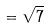<formula> <loc_0><loc_0><loc_500><loc_500>= \sqrt { 7 }</formula> 